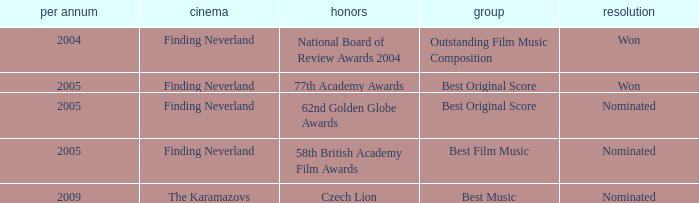What was the result for years prior to 2005? Won. 